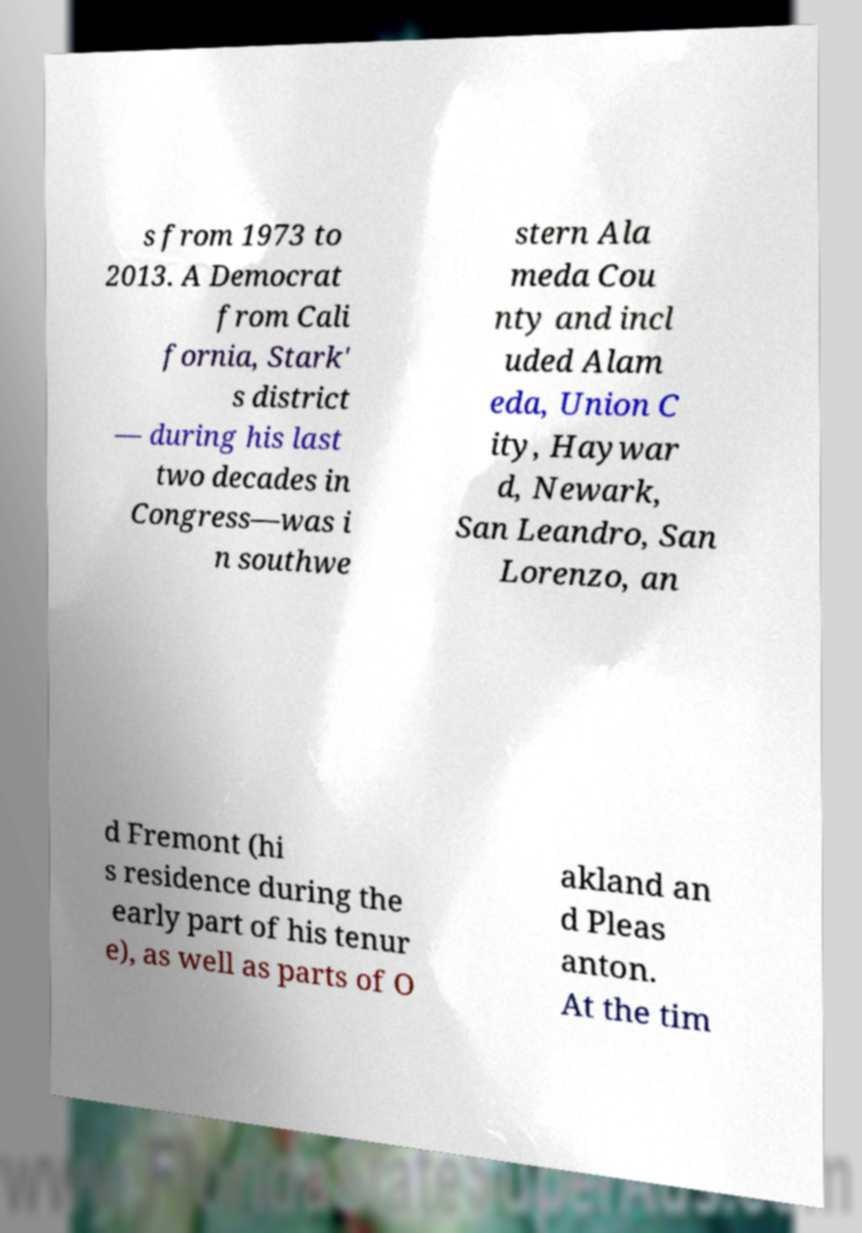Could you assist in decoding the text presented in this image and type it out clearly? s from 1973 to 2013. A Democrat from Cali fornia, Stark' s district — during his last two decades in Congress—was i n southwe stern Ala meda Cou nty and incl uded Alam eda, Union C ity, Haywar d, Newark, San Leandro, San Lorenzo, an d Fremont (hi s residence during the early part of his tenur e), as well as parts of O akland an d Pleas anton. At the tim 